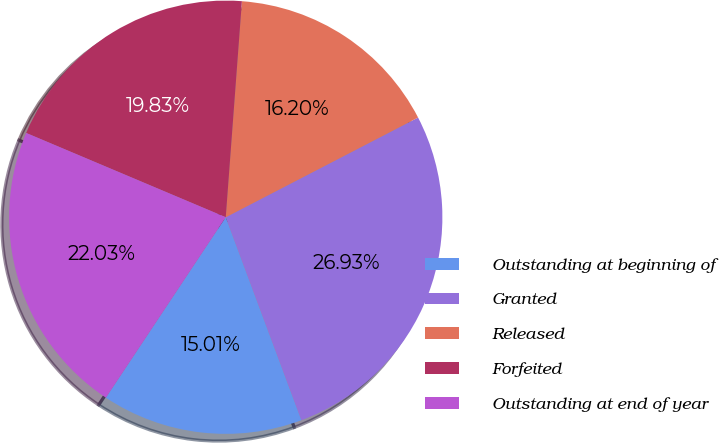Convert chart to OTSL. <chart><loc_0><loc_0><loc_500><loc_500><pie_chart><fcel>Outstanding at beginning of<fcel>Granted<fcel>Released<fcel>Forfeited<fcel>Outstanding at end of year<nl><fcel>15.01%<fcel>26.93%<fcel>16.2%<fcel>19.83%<fcel>22.03%<nl></chart> 